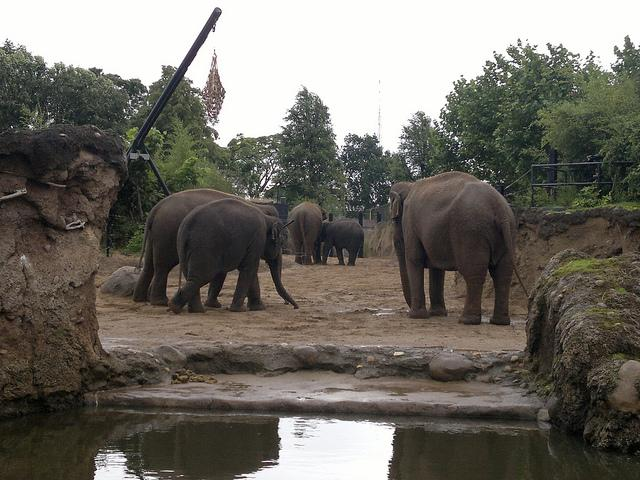What measurement is closest to the weight of the biggest animal here?

Choices:
A) 5 milligrams
B) 3 kilograms
C) 8000 pounds
D) 500 tons 5 milligrams 